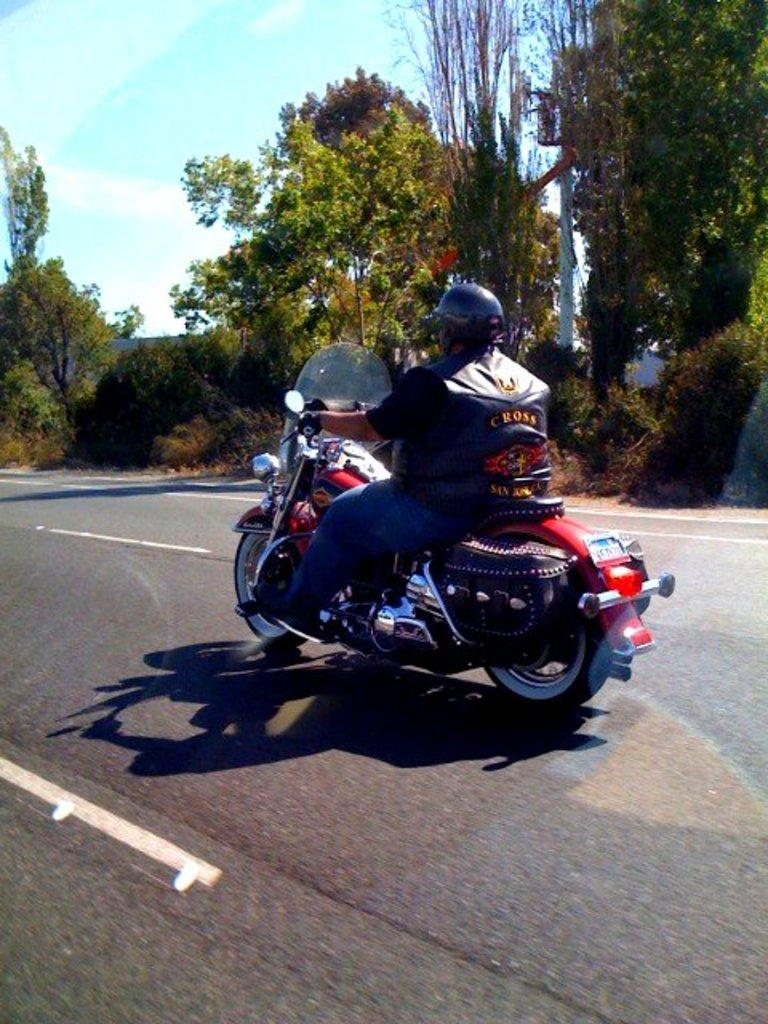What is the main subject of the image? There is a person riding a motorcycle in the image. What safety gear is the person wearing? The person is wearing a helmet. What type of natural environment can be seen in the image? There are trees visible in the right corner of the image. What is the color of the sky in the image? The sky is blue in color. Can you tell me how many animals are present in the zoo in the image? There is no zoo present in the image; it features a person riding a motorcycle. What type of attention is the person receiving while riding the motorcycle in the image? There is no indication of the person receiving any specific type of attention in the image. 